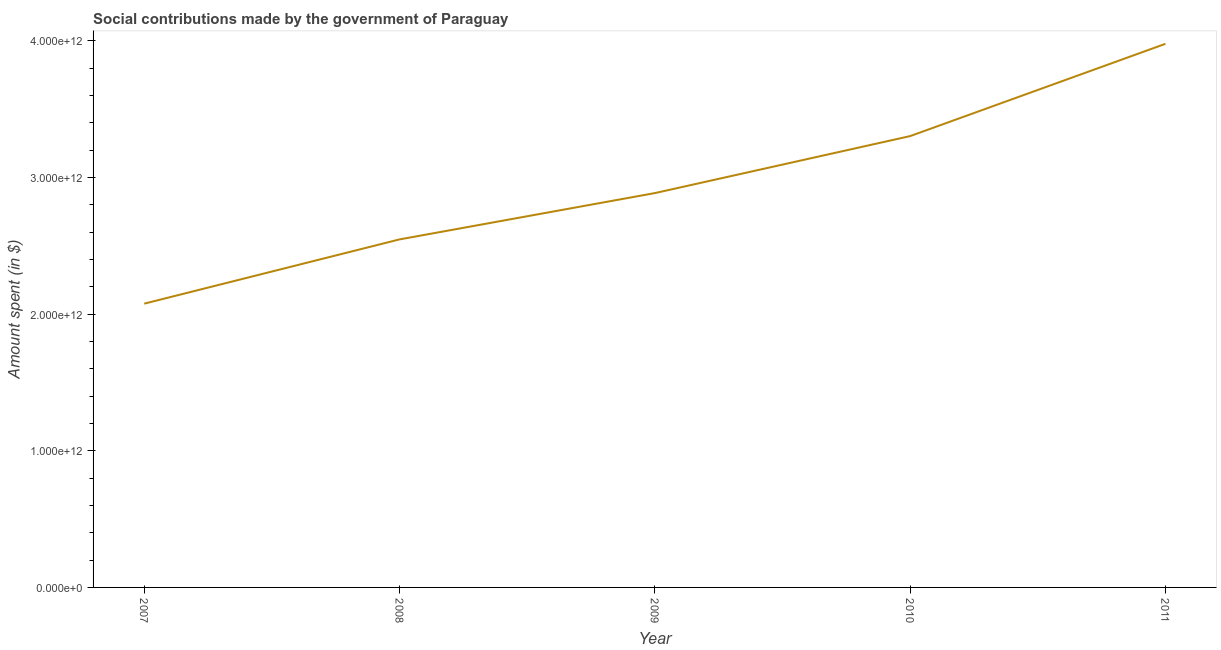What is the amount spent in making social contributions in 2007?
Ensure brevity in your answer.  2.08e+12. Across all years, what is the maximum amount spent in making social contributions?
Provide a succinct answer. 3.98e+12. Across all years, what is the minimum amount spent in making social contributions?
Your answer should be very brief. 2.08e+12. What is the sum of the amount spent in making social contributions?
Offer a very short reply. 1.48e+13. What is the difference between the amount spent in making social contributions in 2010 and 2011?
Your answer should be very brief. -6.76e+11. What is the average amount spent in making social contributions per year?
Offer a very short reply. 2.96e+12. What is the median amount spent in making social contributions?
Give a very brief answer. 2.89e+12. In how many years, is the amount spent in making social contributions greater than 2000000000000 $?
Your answer should be very brief. 5. Do a majority of the years between 2009 and 2011 (inclusive) have amount spent in making social contributions greater than 2600000000000 $?
Provide a short and direct response. Yes. What is the ratio of the amount spent in making social contributions in 2007 to that in 2008?
Offer a very short reply. 0.82. Is the amount spent in making social contributions in 2008 less than that in 2011?
Make the answer very short. Yes. Is the difference between the amount spent in making social contributions in 2008 and 2011 greater than the difference between any two years?
Ensure brevity in your answer.  No. What is the difference between the highest and the second highest amount spent in making social contributions?
Ensure brevity in your answer.  6.76e+11. Is the sum of the amount spent in making social contributions in 2010 and 2011 greater than the maximum amount spent in making social contributions across all years?
Offer a terse response. Yes. What is the difference between the highest and the lowest amount spent in making social contributions?
Keep it short and to the point. 1.90e+12. In how many years, is the amount spent in making social contributions greater than the average amount spent in making social contributions taken over all years?
Ensure brevity in your answer.  2. Does the amount spent in making social contributions monotonically increase over the years?
Your answer should be very brief. Yes. How many lines are there?
Provide a succinct answer. 1. What is the difference between two consecutive major ticks on the Y-axis?
Make the answer very short. 1.00e+12. Does the graph contain any zero values?
Keep it short and to the point. No. Does the graph contain grids?
Provide a short and direct response. No. What is the title of the graph?
Give a very brief answer. Social contributions made by the government of Paraguay. What is the label or title of the Y-axis?
Offer a terse response. Amount spent (in $). What is the Amount spent (in $) of 2007?
Your response must be concise. 2.08e+12. What is the Amount spent (in $) in 2008?
Make the answer very short. 2.55e+12. What is the Amount spent (in $) of 2009?
Ensure brevity in your answer.  2.89e+12. What is the Amount spent (in $) of 2010?
Your answer should be compact. 3.30e+12. What is the Amount spent (in $) in 2011?
Offer a terse response. 3.98e+12. What is the difference between the Amount spent (in $) in 2007 and 2008?
Make the answer very short. -4.70e+11. What is the difference between the Amount spent (in $) in 2007 and 2009?
Ensure brevity in your answer.  -8.09e+11. What is the difference between the Amount spent (in $) in 2007 and 2010?
Your response must be concise. -1.23e+12. What is the difference between the Amount spent (in $) in 2007 and 2011?
Offer a very short reply. -1.90e+12. What is the difference between the Amount spent (in $) in 2008 and 2009?
Keep it short and to the point. -3.39e+11. What is the difference between the Amount spent (in $) in 2008 and 2010?
Your response must be concise. -7.56e+11. What is the difference between the Amount spent (in $) in 2008 and 2011?
Your response must be concise. -1.43e+12. What is the difference between the Amount spent (in $) in 2009 and 2010?
Give a very brief answer. -4.17e+11. What is the difference between the Amount spent (in $) in 2009 and 2011?
Provide a succinct answer. -1.09e+12. What is the difference between the Amount spent (in $) in 2010 and 2011?
Give a very brief answer. -6.76e+11. What is the ratio of the Amount spent (in $) in 2007 to that in 2008?
Your response must be concise. 0.81. What is the ratio of the Amount spent (in $) in 2007 to that in 2009?
Provide a short and direct response. 0.72. What is the ratio of the Amount spent (in $) in 2007 to that in 2010?
Provide a succinct answer. 0.63. What is the ratio of the Amount spent (in $) in 2007 to that in 2011?
Offer a terse response. 0.52. What is the ratio of the Amount spent (in $) in 2008 to that in 2009?
Give a very brief answer. 0.88. What is the ratio of the Amount spent (in $) in 2008 to that in 2010?
Make the answer very short. 0.77. What is the ratio of the Amount spent (in $) in 2008 to that in 2011?
Make the answer very short. 0.64. What is the ratio of the Amount spent (in $) in 2009 to that in 2010?
Make the answer very short. 0.87. What is the ratio of the Amount spent (in $) in 2009 to that in 2011?
Provide a succinct answer. 0.72. What is the ratio of the Amount spent (in $) in 2010 to that in 2011?
Your response must be concise. 0.83. 